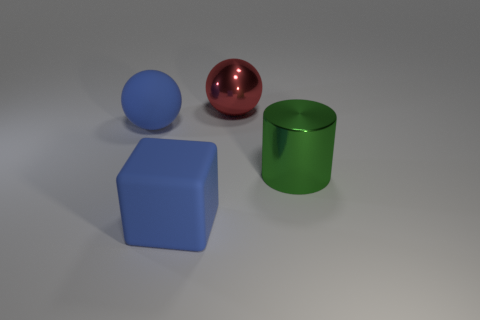What number of cylinders are tiny shiny things or big green things?
Offer a terse response. 1. How many other objects are there of the same material as the green cylinder?
Your response must be concise. 1. What shape is the metallic thing that is on the left side of the green object?
Offer a very short reply. Sphere. There is a sphere that is behind the blue rubber thing that is behind the big metal cylinder; what is it made of?
Offer a very short reply. Metal. Are there more large spheres that are left of the red metallic sphere than small blue matte cylinders?
Provide a succinct answer. Yes. What number of other objects are there of the same color as the large cube?
Make the answer very short. 1. The red object that is the same size as the metal cylinder is what shape?
Offer a terse response. Sphere. How many green cylinders are on the right side of the green shiny object that is on the right side of the blue object that is in front of the big blue ball?
Your answer should be compact. 0. How many matte things are either blocks or big things?
Your answer should be very brief. 2. The thing that is both behind the large cylinder and in front of the large metallic sphere is what color?
Your answer should be very brief. Blue. 